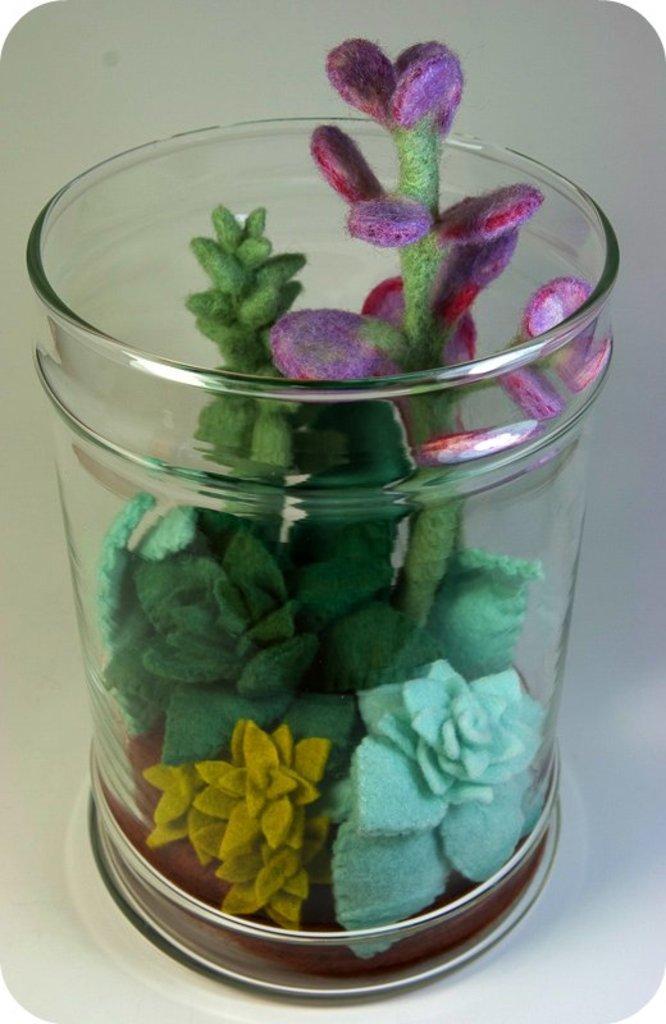How would you summarize this image in a sentence or two? In the foreground of this image, there is an artificial flower vase on the white surface. 